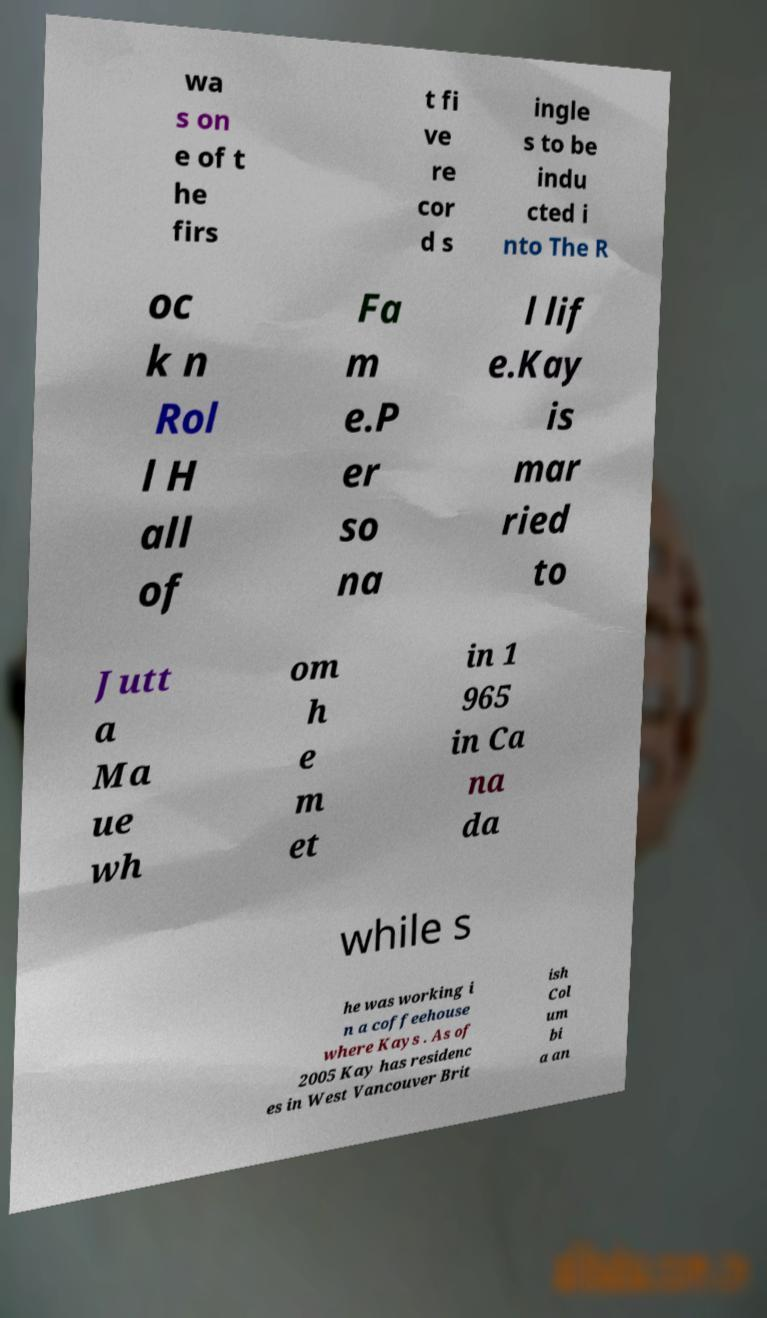Can you accurately transcribe the text from the provided image for me? wa s on e of t he firs t fi ve re cor d s ingle s to be indu cted i nto The R oc k n Rol l H all of Fa m e.P er so na l lif e.Kay is mar ried to Jutt a Ma ue wh om h e m et in 1 965 in Ca na da while s he was working i n a coffeehouse where Kays . As of 2005 Kay has residenc es in West Vancouver Brit ish Col um bi a an 